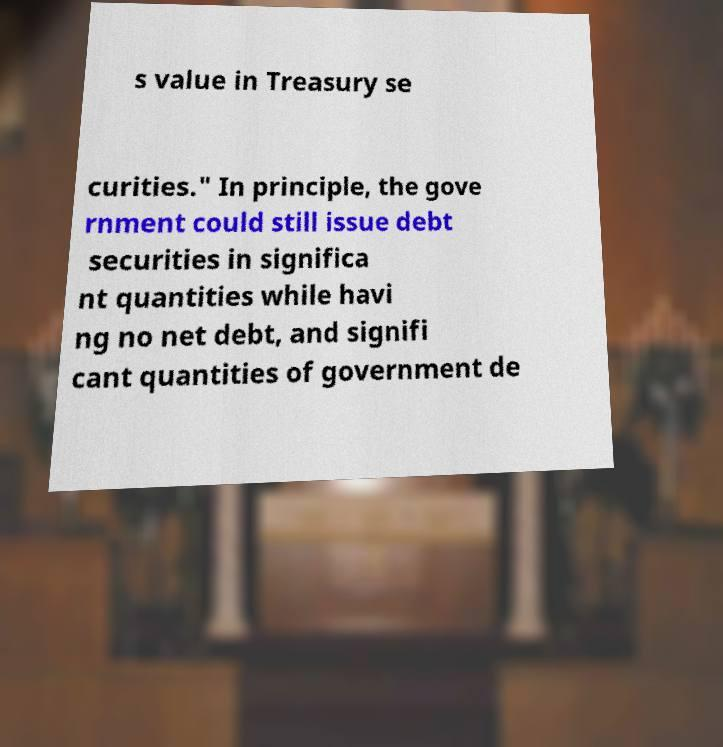Please read and relay the text visible in this image. What does it say? s value in Treasury se curities." In principle, the gove rnment could still issue debt securities in significa nt quantities while havi ng no net debt, and signifi cant quantities of government de 